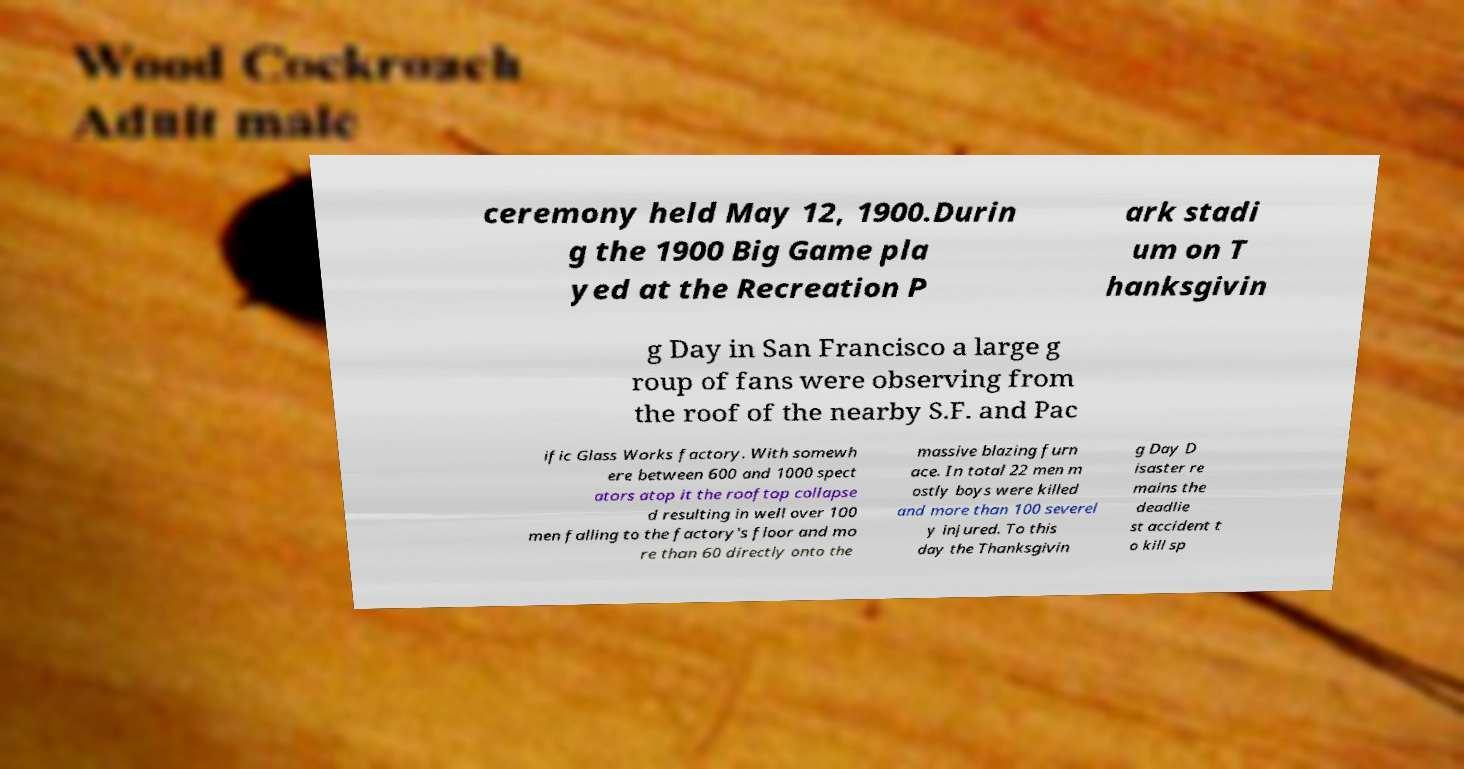There's text embedded in this image that I need extracted. Can you transcribe it verbatim? ceremony held May 12, 1900.Durin g the 1900 Big Game pla yed at the Recreation P ark stadi um on T hanksgivin g Day in San Francisco a large g roup of fans were observing from the roof of the nearby S.F. and Pac ific Glass Works factory. With somewh ere between 600 and 1000 spect ators atop it the rooftop collapse d resulting in well over 100 men falling to the factory's floor and mo re than 60 directly onto the massive blazing furn ace. In total 22 men m ostly boys were killed and more than 100 severel y injured. To this day the Thanksgivin g Day D isaster re mains the deadlie st accident t o kill sp 